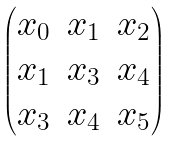Convert formula to latex. <formula><loc_0><loc_0><loc_500><loc_500>\begin{pmatrix} x _ { 0 } & x _ { 1 } & x _ { 2 } \\ x _ { 1 } & x _ { 3 } & x _ { 4 } \\ x _ { 3 } & x _ { 4 } & x _ { 5 } \end{pmatrix}</formula> 